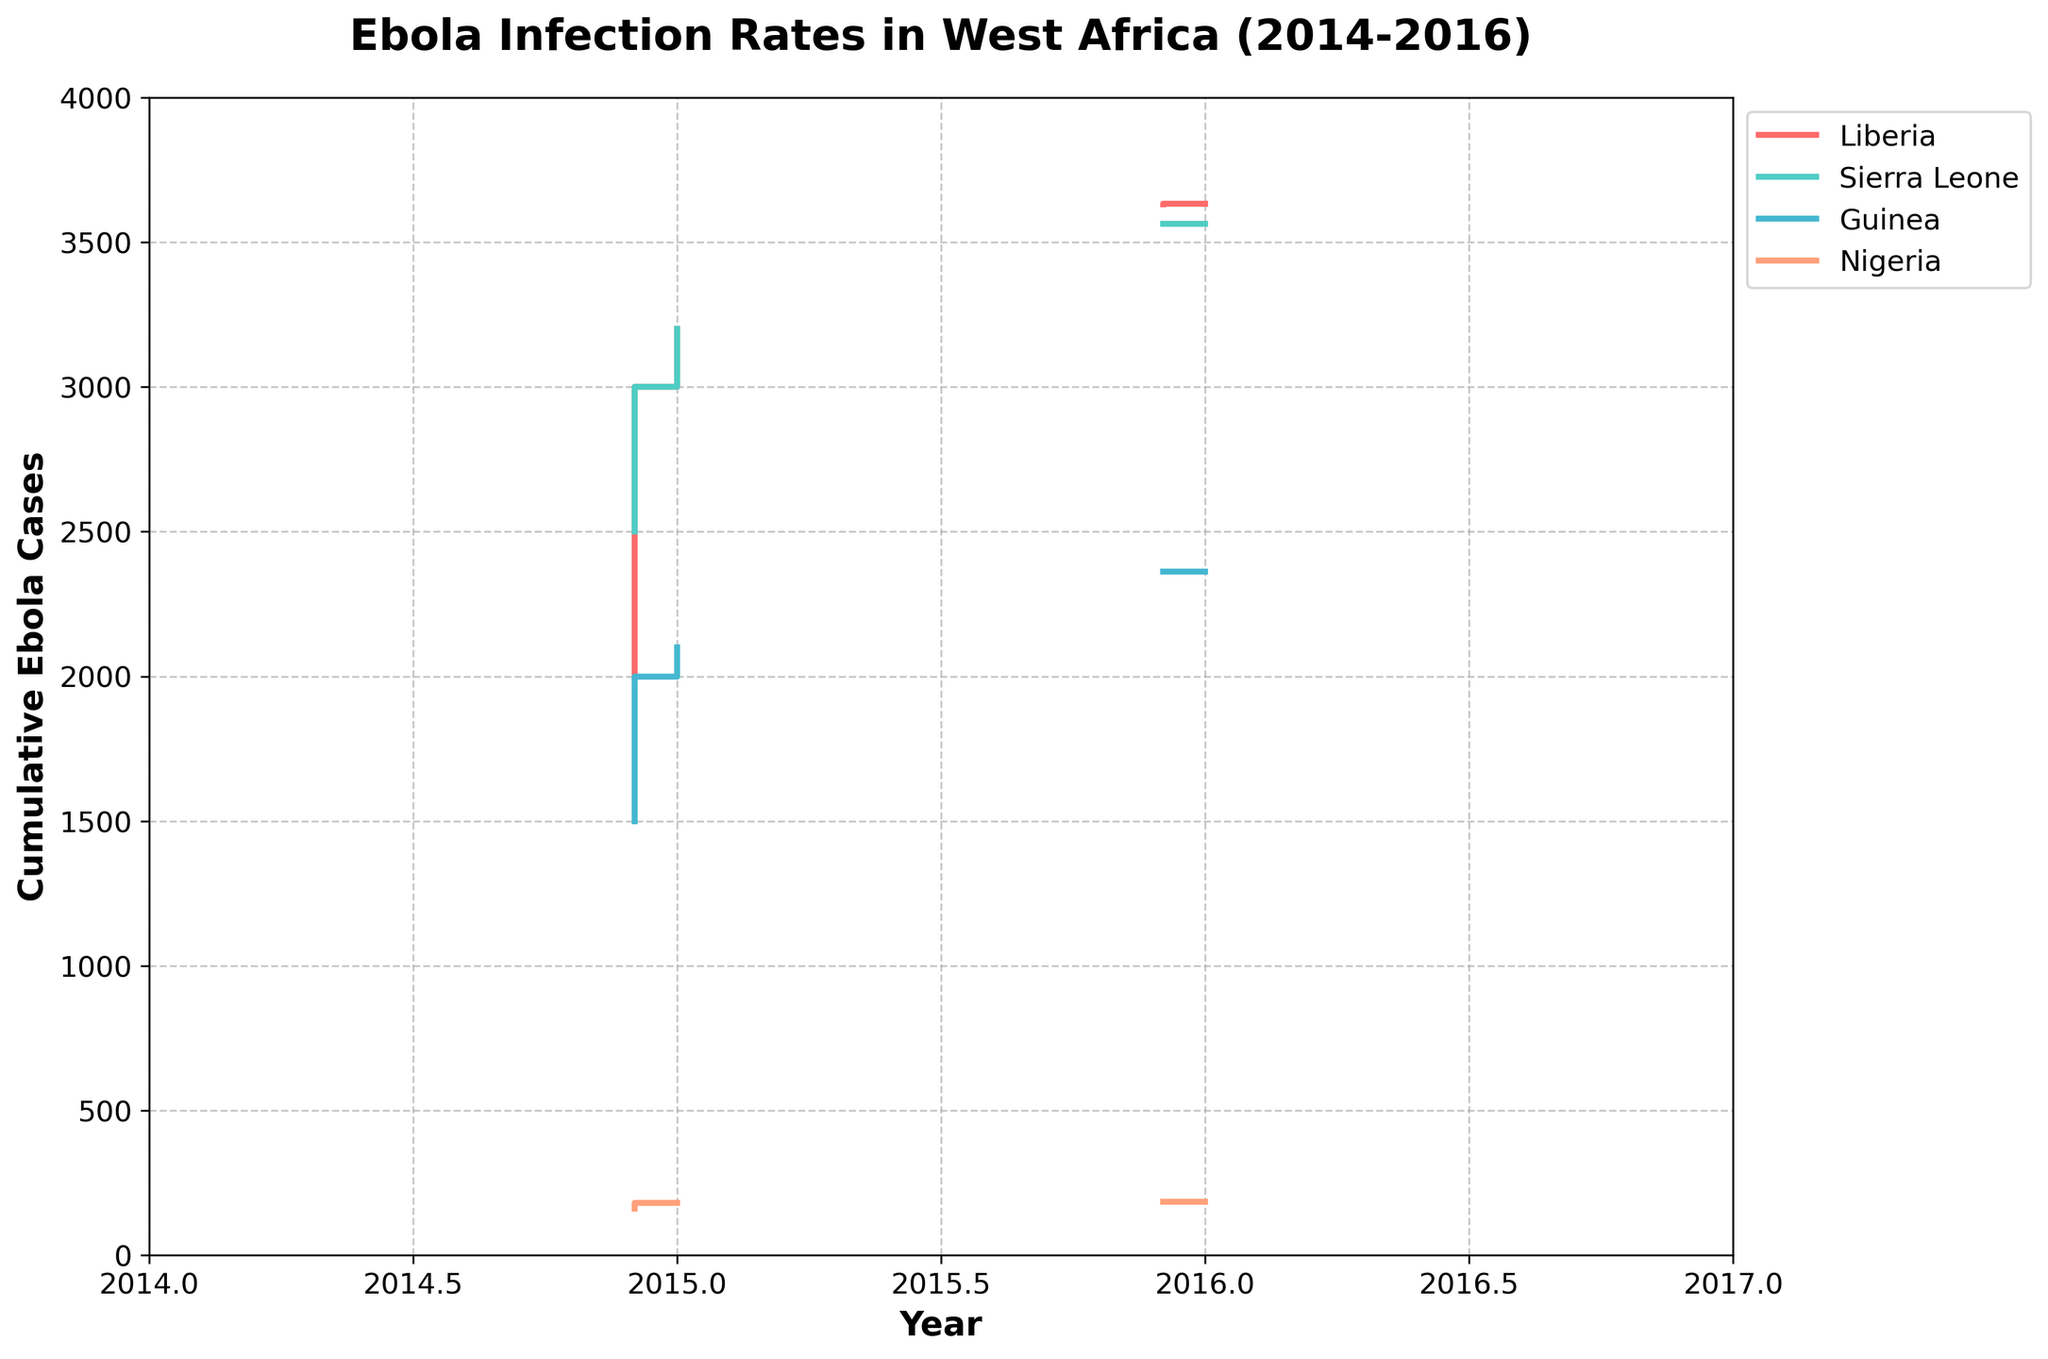What is the title of the plot? The title of the plot is located at the top of the figure and it states what the plot is about.
Answer: Ebola Infection Rates in West Africa (2014-2016) Which country had the highest number of cumulative Ebola cases by the end of 2014? Look at the year 2014 and trace the highest step at the end of December. The steps are color-coded, and the highest step is 3000 in red, which corresponds to Liberia.
Answer: Liberia How many cumulative Ebola cases were reported in Guinea by August 2014? Follow the green-colored steps up to August 2014 and see the corresponding value on the y-axis.
Answer: 600 Which country had fewer cumulative Ebola cases in November 2014, Nigeria or Guinea? Compare the heights of the gray and green steps for November 2014. Guinea has a higher step than Nigeria, implying Nigeria had fewer cases.
Answer: Nigeria In which month of 2014 did Liberia surpass 1500 cumulative Ebola cases? Follow the red steps representing Liberia and identify the month where the step height exceeds 1500. This happens in October 2014.
Answer: October What is the cumulative number of Ebola cases in Sierra Leone by the end of 2015? Trace the light blue-colored steps up to December 2015 and read off the y-axis value.
Answer: 3563 By how many cases did the cumulative number of Ebola cases in Nigeria increase between June 2014 and June 2015? Find the cumulative Ebola cases in Nigeria for June 2014 and June 2015, then calculate the difference (185 - 10 = 175).
Answer: 175 Which country had the steadiest increase in Ebola cases from 2014 to 2016? Look at the slope of each country's steps from start to end. Sierra Leone (light blue) and Guinea (green) have comparatively steadier slopes, suggesting steady increases, but Sierra Leone is incrementally more linear.
Answer: Sierra Leone What is the approximate month when Liberia's cumulative Ebola cases reach a plateau? Observe the red steps and identify the time when the steps almost stop increasing significantly. The plateau can be seen starting in early 2015.
Answer: Early 2015 Compare the cumulative cases in Sierra Leone and Guinea at their peaks during the observed period. Which country had more cases, and by approximately how many? Find the highest steps for Sierra Leone (3563) and Guinea (2362), then calculate the difference (3563 - 2362 = 1201). Sierra Leone had more cases.
Answer: Sierra Leone, by approximately 1201 